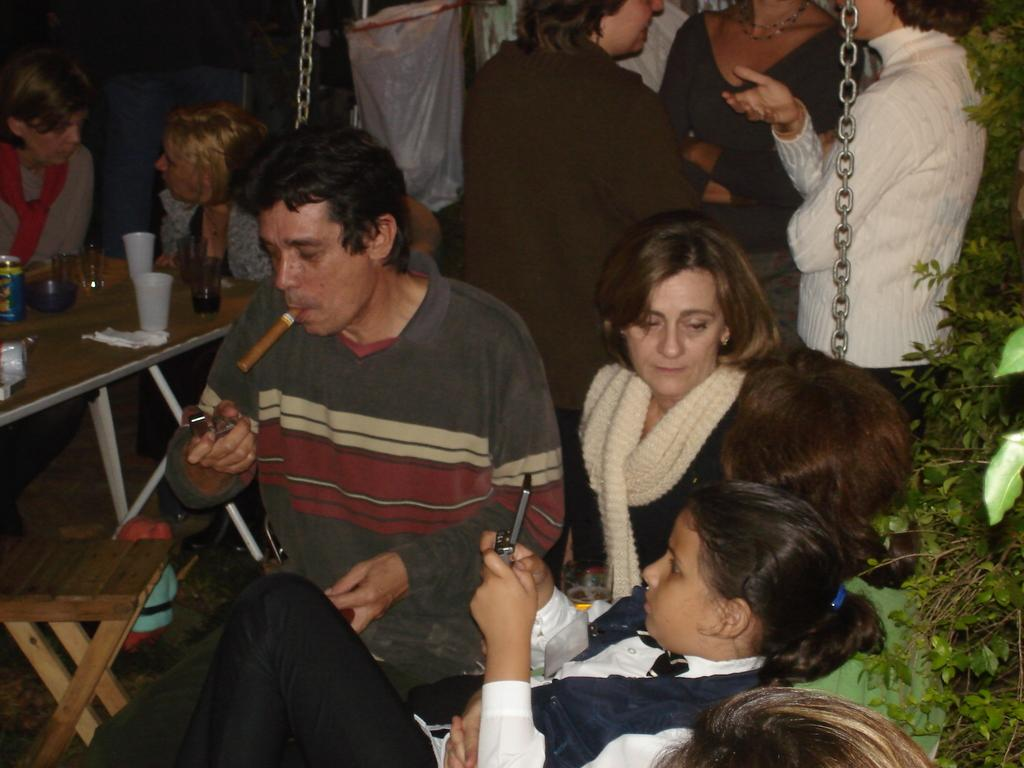What are the people in the image doing? There is a group of people sitting in the image. What is in front of the sitting group? There is a table in front of the sitting group. What can be seen on the table? There are objects on the table. Are there any other people in the image? Yes, there is a group of people standing at the back. What type of hen is present on the page in the image? There is no hen or page present in the image. 